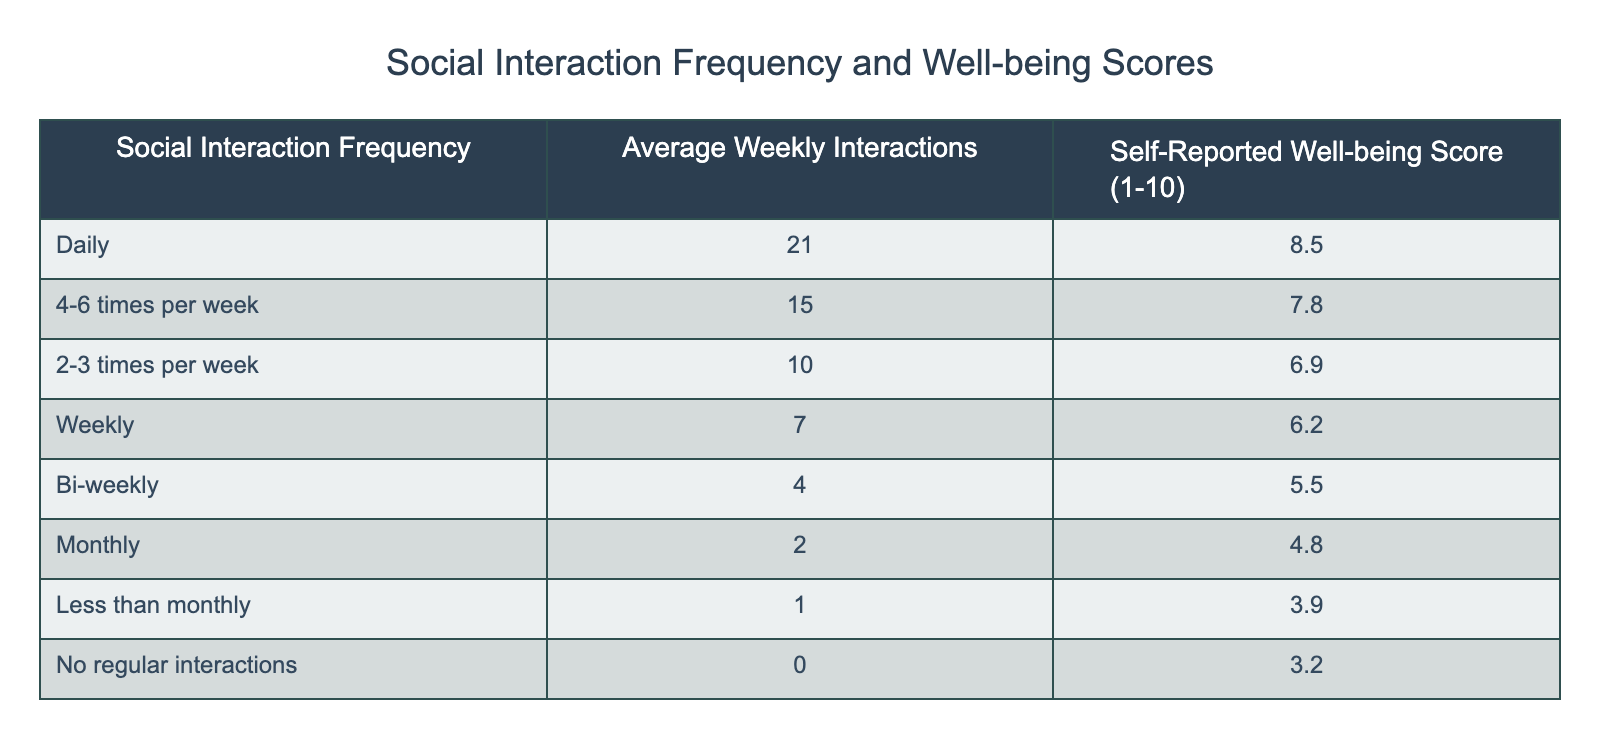What is the self-reported well-being score for those who interact socially daily? The table shows that for the category labeled "Daily," the corresponding self-reported well-being score is 8.5.
Answer: 8.5 How many average weekly interactions do people report when they have no regular interactions? According to the table, for the category "No regular interactions," the average weekly interactions are 0.
Answer: 0 What is the highest self-reported well-being score recorded in the table? The table indicates that the highest self-reported well-being score is 8.5, which corresponds to the "Daily" interaction frequency.
Answer: 8.5 If someone interacts socially 2-3 times per week, what is the difference between their well-being score and that of someone who interacts weekly? The well-being score for "2-3 times per week" is 6.9, and for "Weekly," it is 6.2. The difference is 6.9 - 6.2 = 0.7.
Answer: 0.7 Is the average weekly interactions for those who interact monthly greater than those who interact bi-weekly? The table shows that "Monthly" interactions have an average of 2, while "Bi-weekly" interactions have an average of 4. Since 2 is not greater than 4, the statement is false.
Answer: No What is the average self-reported well-being score for all interaction categories combined? To find the average, we sum the well-being scores: (8.5 + 7.8 + 6.9 + 6.2 + 5.5 + 4.8 + 3.9 + 3.2) = 46.8. There are 8 categories, so the average is 46.8 / 8 = 5.85.
Answer: 5.85 How many average weekly interactions correspond to a self-reported well-being score of 5.5? In the table, the "Bi-weekly" interaction category corresponds to an average of 4 weekly interactions, which also has a well-being score of 5.5.
Answer: 4 Are there any categories where the average weekly interactions are more than 15? The "4-6 times per week" category has an average of 15, but no category exceeds this value, making the answer false.
Answer: No How does the self-reported well-being score change as the frequency of social interactions decreases from daily to less than monthly? Analyzing the scores, we observe that the score decreases from 8.5 (Daily) to 3.2 (No regular interactions), indicating a trend of decreasing well-being with decreased interaction frequency.
Answer: It decreases 